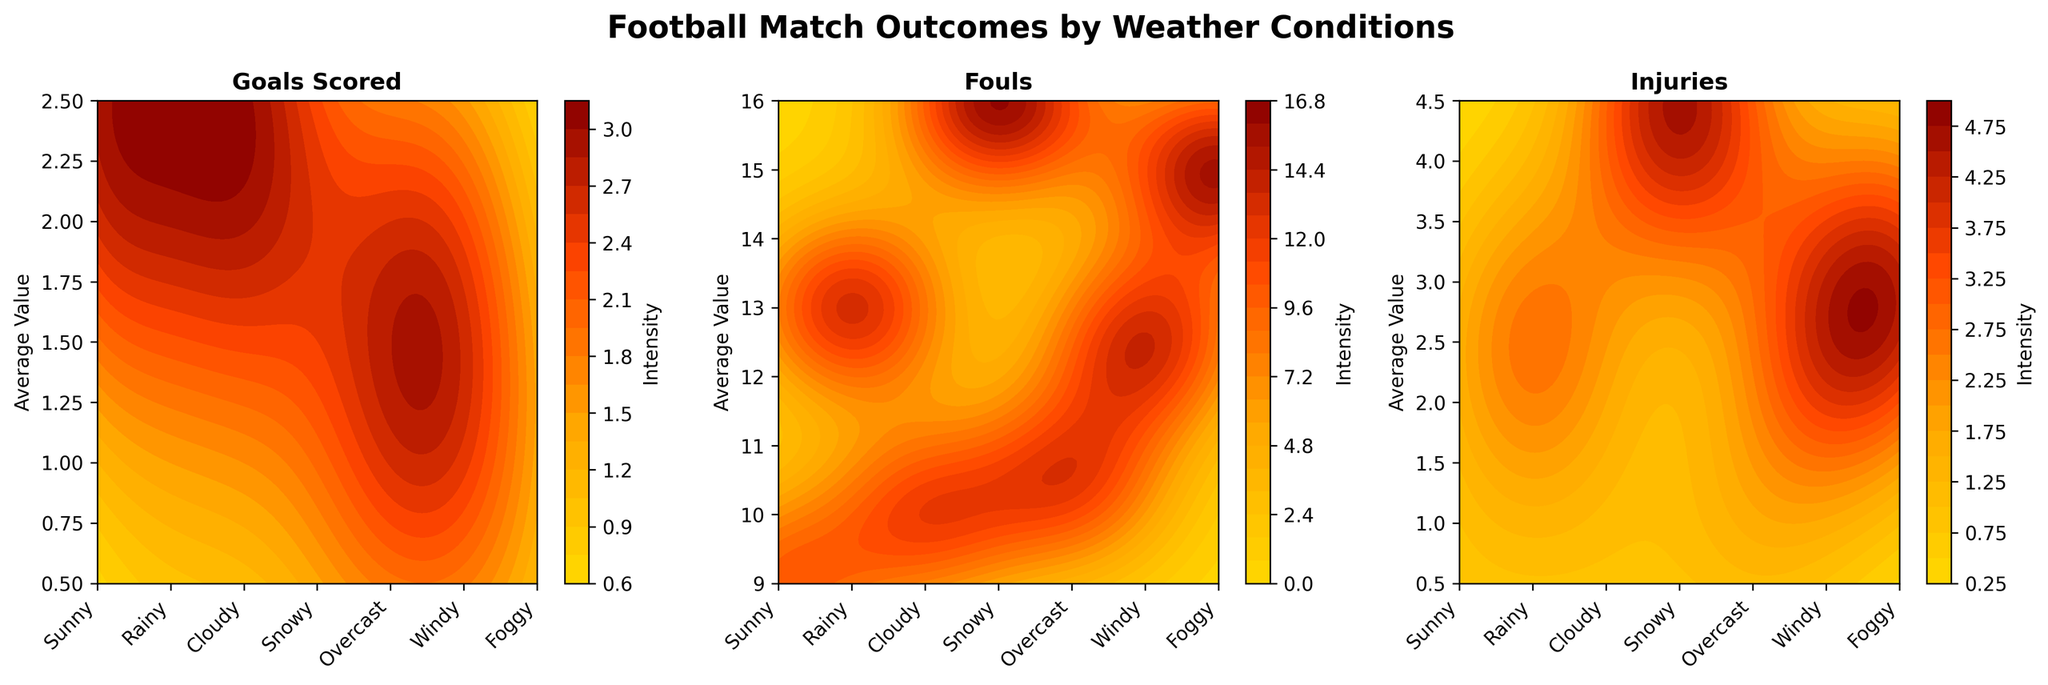How many weather conditions are displayed in the figure? The x-axis of the plot displays distinct weather conditions. Counting each unique label, we find the total.
Answer: 7 What is the title of the figure? The figure title is written at the top of the chart.
Answer: Football Match Outcomes by Weather Conditions Which weather condition seems to have the highest average number of injuries? By examining the contour plots for the subplot titled "Injuries," the highest intensity color corresponds to the weather condition with the highest average number of injuries.
Answer: Snowy What's the difference in average number of fouls between "Rainy" and "Windy" conditions? Locate "Rainy" and "Windy" on the x-axis of the fouls subplot, find their values and calculate the difference.
Answer: 2 Which subplot shows the highest intensity value for "Sunny" condition? For each subplot, look for how high the intensity color reaches for the Sunny condition. The subplot with the most saturated color represents the highest intensity.
Answer: Goals Scored What weather condition appears to have the lowest average number of goals scored? In the "Goals Scored" subplot, identify the condition with the least intense color on the intensity scale.
Answer: Snowy Compare the average fouls made during "Cloudy" and "Overcast" weather conditions and identify which is higher. Find the average number of fouls for "Cloudy" and "Overcast" from the corresponding positions on the subplot and compare them.
Answer: Overcast What’s the average number of injuries in "Foggy" weather according to the plot? Look at the "Injuries" subplot, find the average value for "Foggy" by examining the contour's intensity.
Answer: 3 Is the average number of injuries higher in "Rainy" weather or "Windy" weather? Compare the average injuries between "Rainy" and "Windy" by checking their respective contour intensity levels.
Answer: Windy 